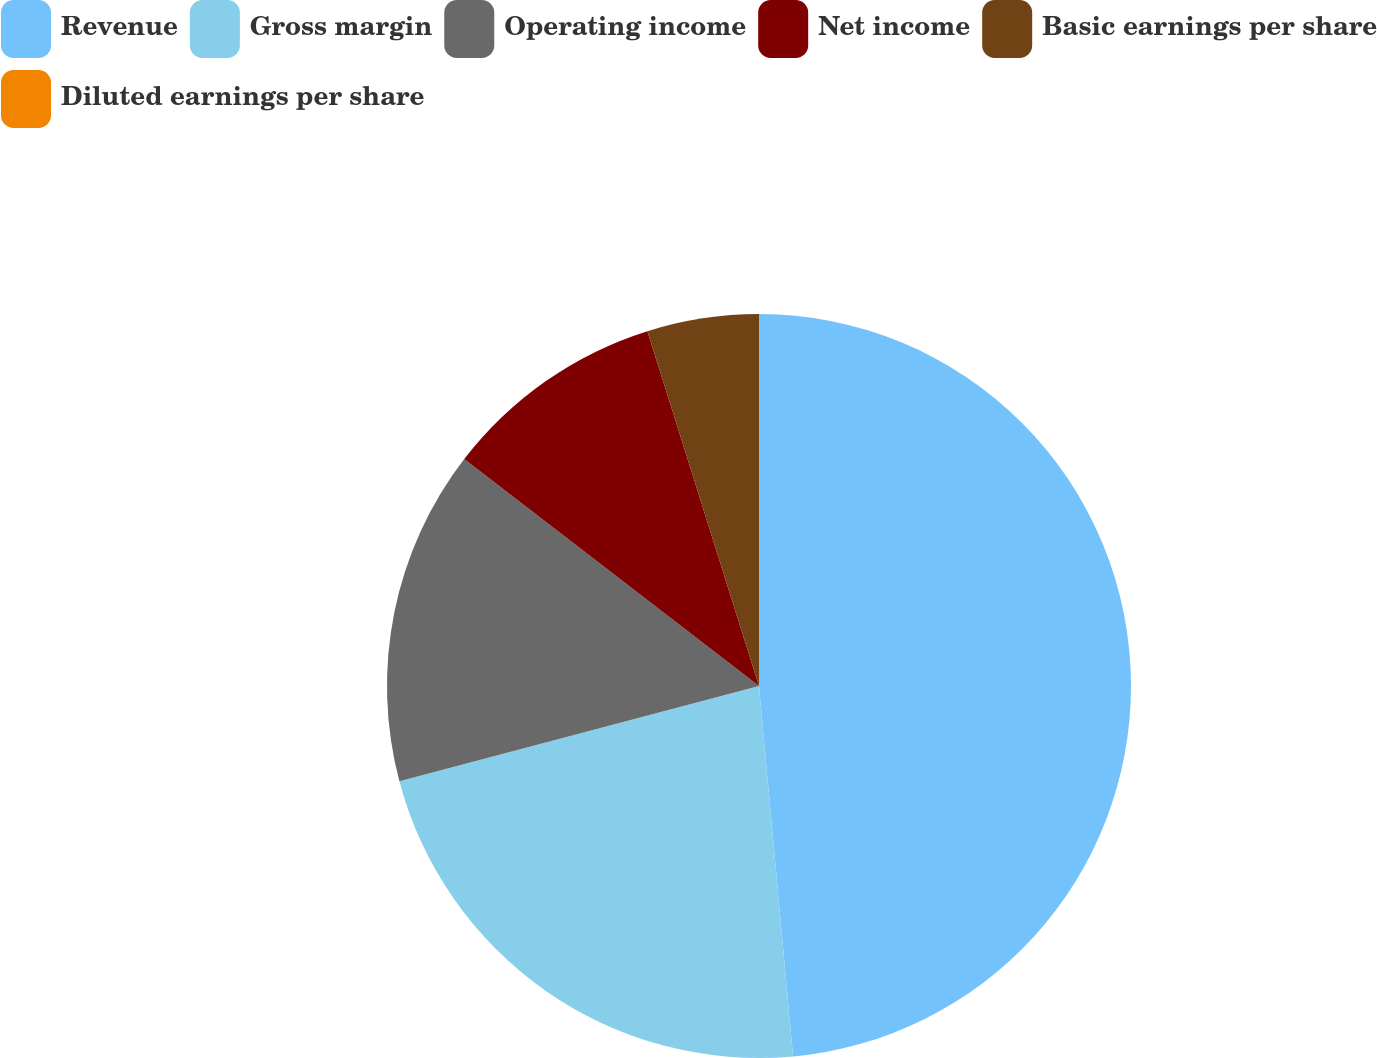Convert chart. <chart><loc_0><loc_0><loc_500><loc_500><pie_chart><fcel>Revenue<fcel>Gross margin<fcel>Operating income<fcel>Net income<fcel>Basic earnings per share<fcel>Diluted earnings per share<nl><fcel>48.54%<fcel>22.34%<fcel>14.56%<fcel>9.71%<fcel>4.85%<fcel>0.0%<nl></chart> 